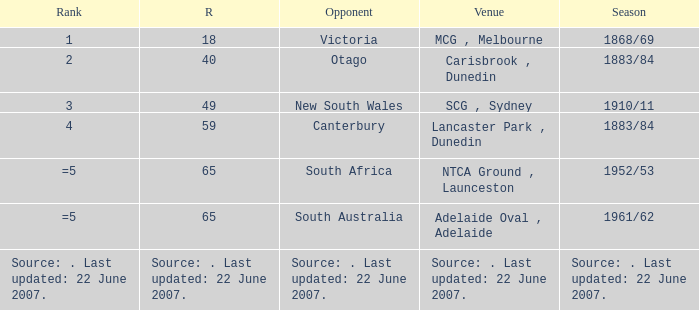Which Runs has a Rank of =5 and an Opponent of south australia? 65.0. 